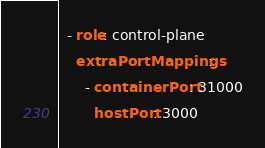<code> <loc_0><loc_0><loc_500><loc_500><_YAML_>  - role: control-plane
    extraPortMappings:
      - containerPort: 31000
        hostPort: 3000
</code> 